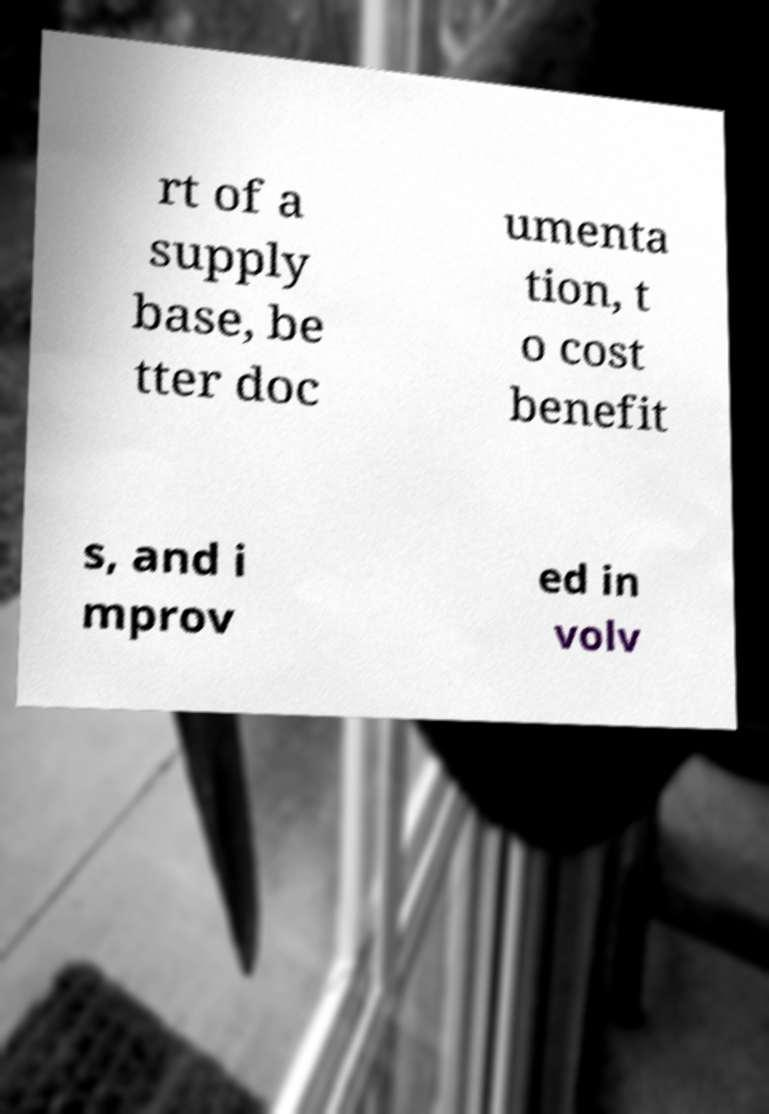For documentation purposes, I need the text within this image transcribed. Could you provide that? rt of a supply base, be tter doc umenta tion, t o cost benefit s, and i mprov ed in volv 